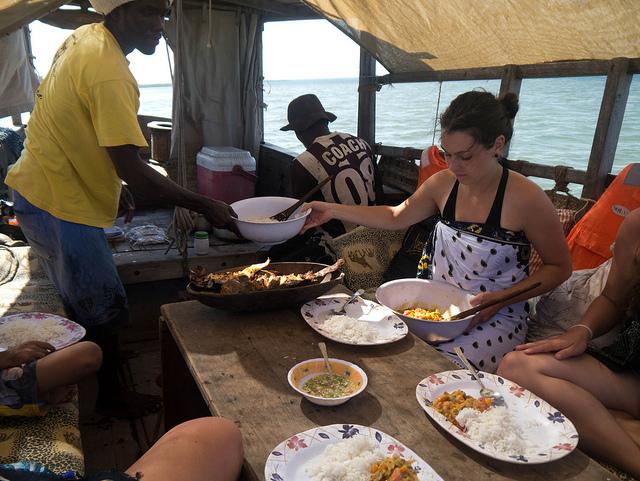What are the people in the photograph preparing to do?
Keep it brief. Eat. How many dishes are on the table?
Quick response, please. 5. Is there a boat in this picture?
Quick response, please. Yes. 